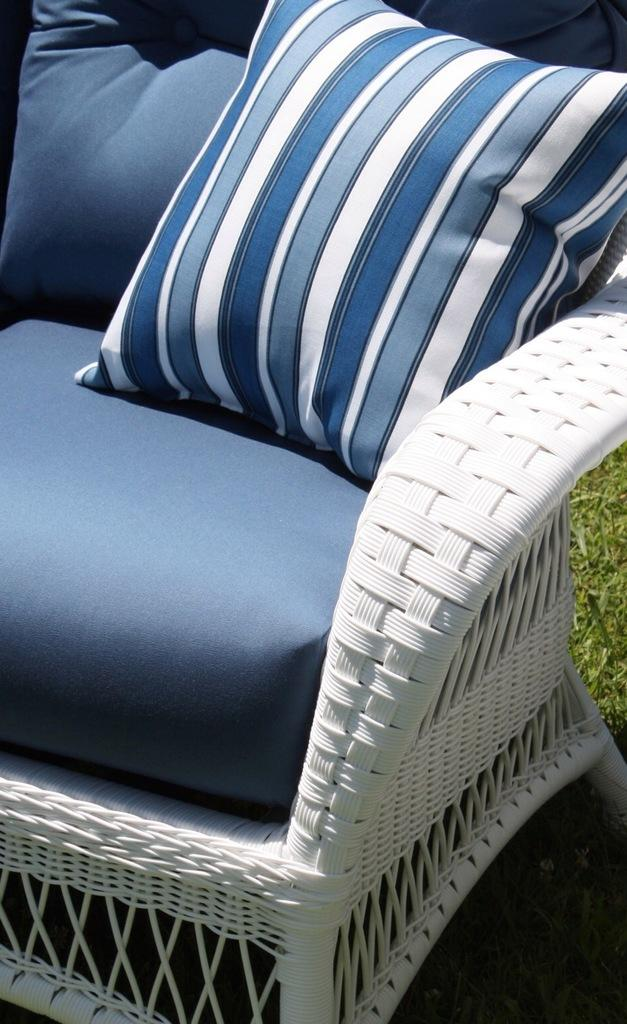What type of seating is present in the image? There is a white sofa in the image. What color is the cushion on the sofa? The cushion on the sofa has a blue color. Is there any other seating in the image? Yes, there is a chair behind the sofa. What can be seen in the background of the image? Grass is visible in the image. Are there any chickens present at the feast in the image? There is no feast or chickens present in the image; it features a white sofa with a blue cushion and a chair behind it, with grass visible in the background. 